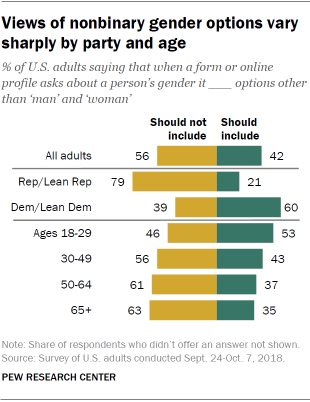List a handful of essential elements in this visual. The second yellow bar from the bottom has a value of 61. The median of the first yellow bar from the top is 2.3625 times the median of the first green bar from the top. 